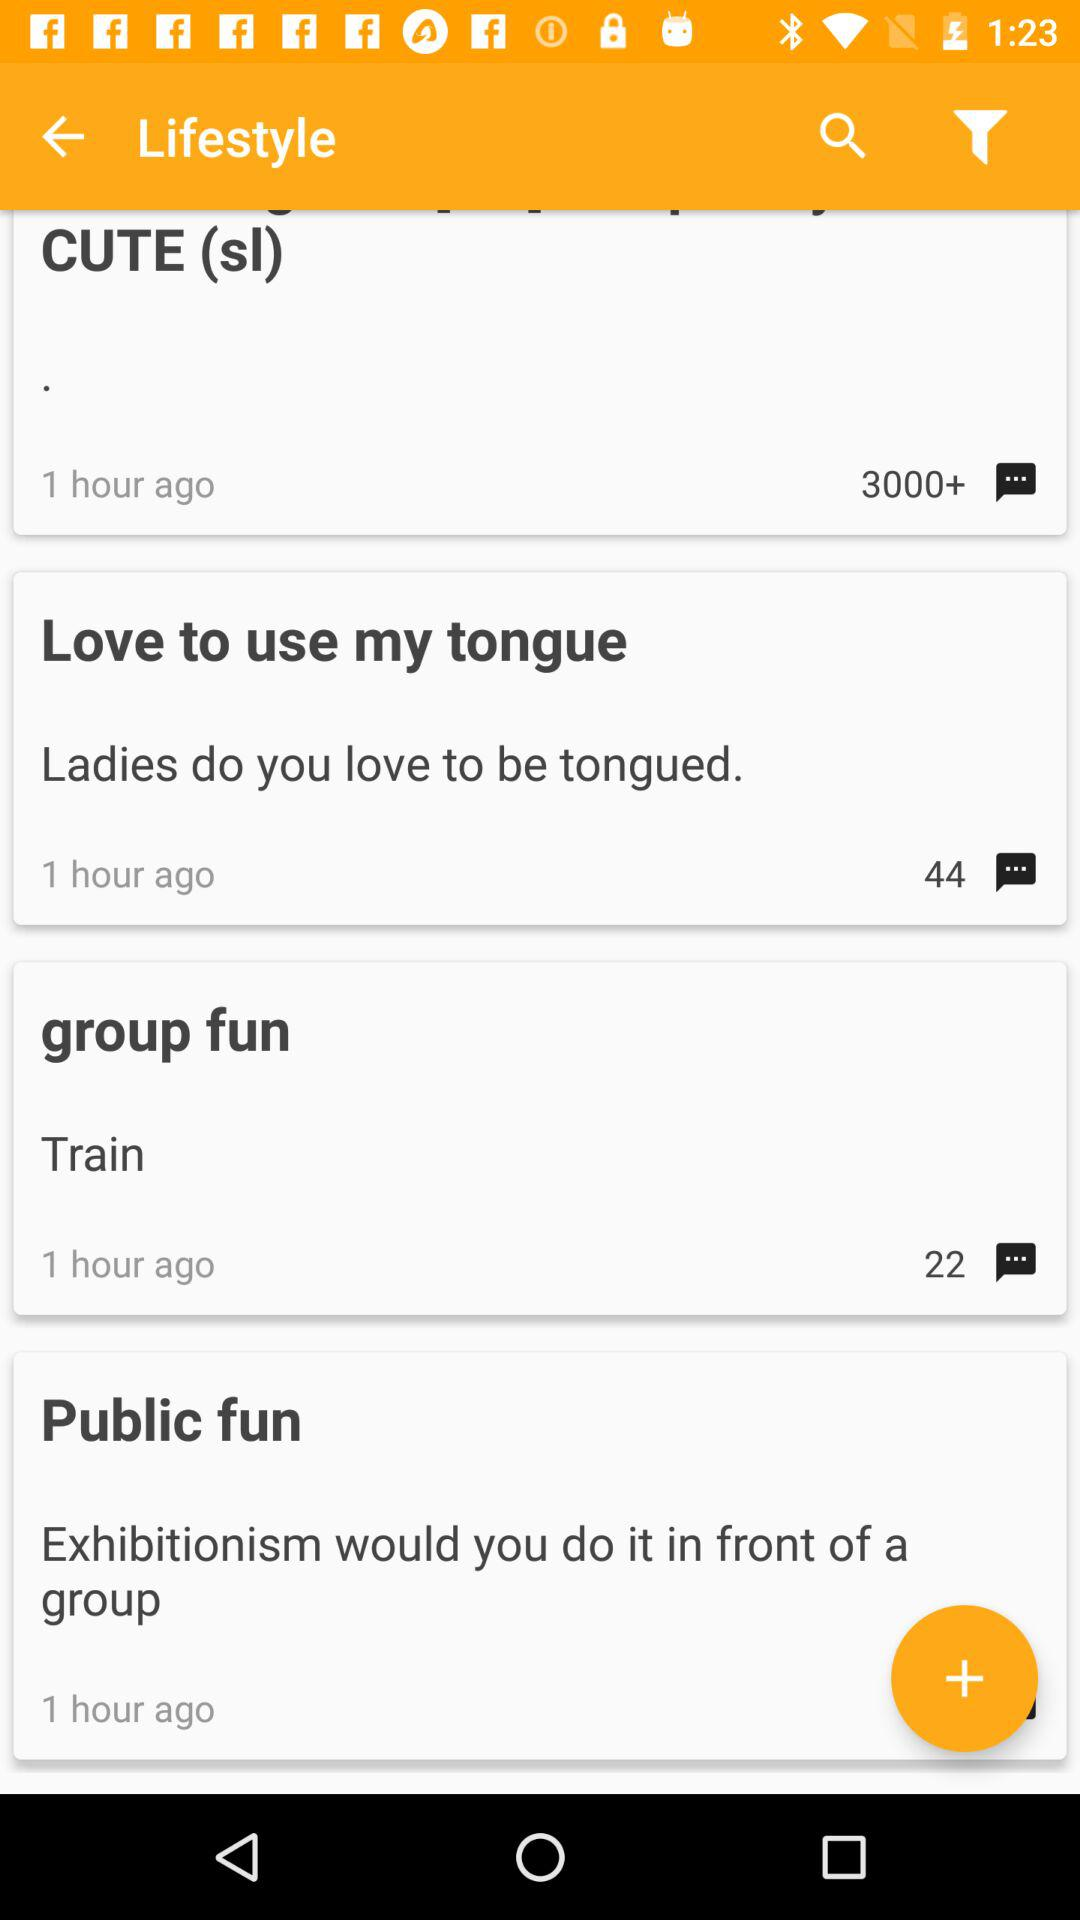How many comments are there in the "Love to use my tongue"? There are 44 comments. 